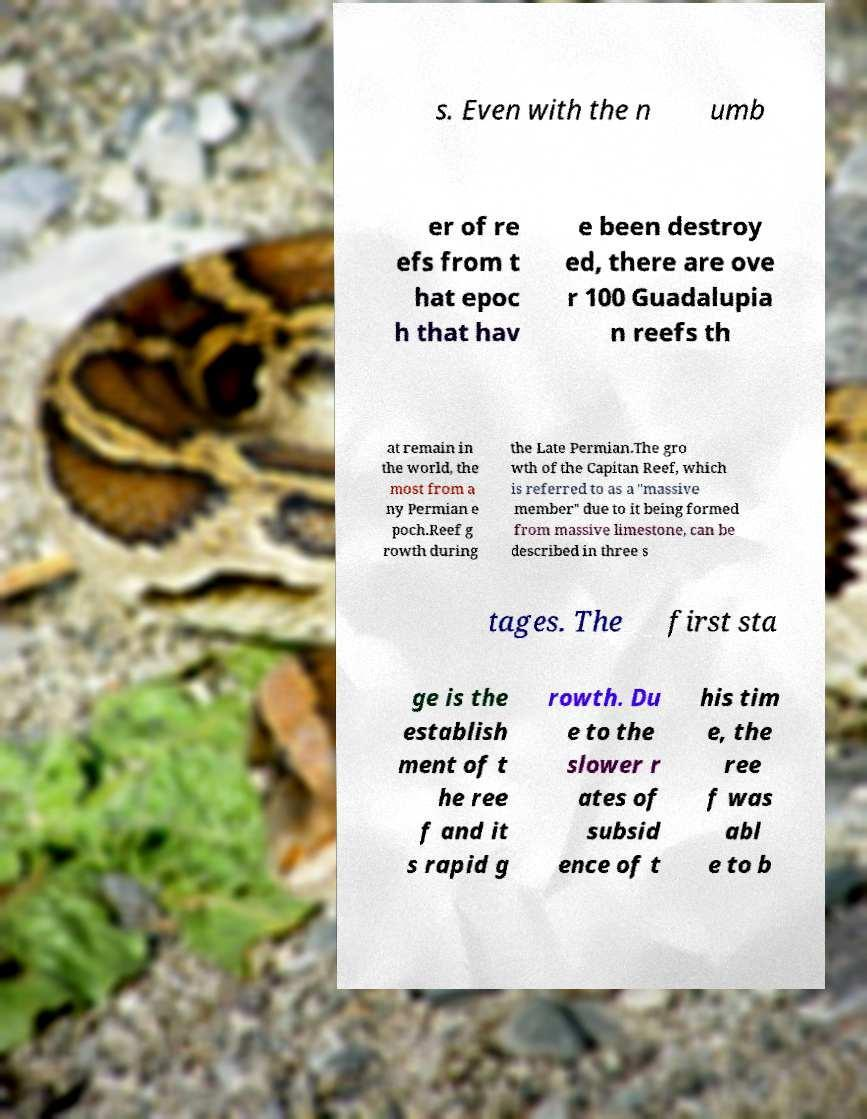Could you extract and type out the text from this image? s. Even with the n umb er of re efs from t hat epoc h that hav e been destroy ed, there are ove r 100 Guadalupia n reefs th at remain in the world, the most from a ny Permian e poch.Reef g rowth during the Late Permian.The gro wth of the Capitan Reef, which is referred to as a "massive member" due to it being formed from massive limestone, can be described in three s tages. The first sta ge is the establish ment of t he ree f and it s rapid g rowth. Du e to the slower r ates of subsid ence of t his tim e, the ree f was abl e to b 